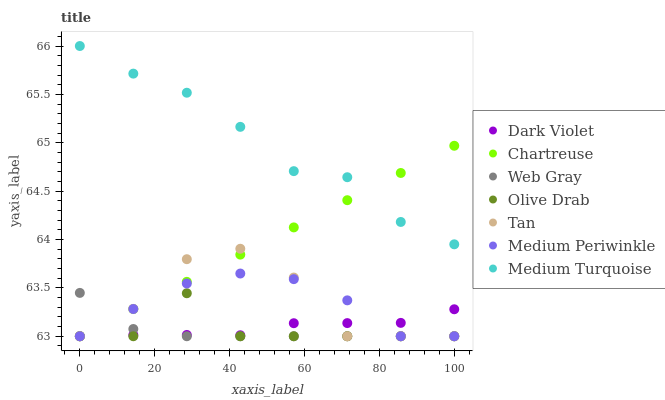Does Web Gray have the minimum area under the curve?
Answer yes or no. Yes. Does Medium Turquoise have the maximum area under the curve?
Answer yes or no. Yes. Does Medium Periwinkle have the minimum area under the curve?
Answer yes or no. No. Does Medium Periwinkle have the maximum area under the curve?
Answer yes or no. No. Is Chartreuse the smoothest?
Answer yes or no. Yes. Is Tan the roughest?
Answer yes or no. Yes. Is Medium Periwinkle the smoothest?
Answer yes or no. No. Is Medium Periwinkle the roughest?
Answer yes or no. No. Does Web Gray have the lowest value?
Answer yes or no. Yes. Does Medium Turquoise have the lowest value?
Answer yes or no. No. Does Medium Turquoise have the highest value?
Answer yes or no. Yes. Does Medium Periwinkle have the highest value?
Answer yes or no. No. Is Olive Drab less than Medium Turquoise?
Answer yes or no. Yes. Is Medium Turquoise greater than Tan?
Answer yes or no. Yes. Does Chartreuse intersect Web Gray?
Answer yes or no. Yes. Is Chartreuse less than Web Gray?
Answer yes or no. No. Is Chartreuse greater than Web Gray?
Answer yes or no. No. Does Olive Drab intersect Medium Turquoise?
Answer yes or no. No. 